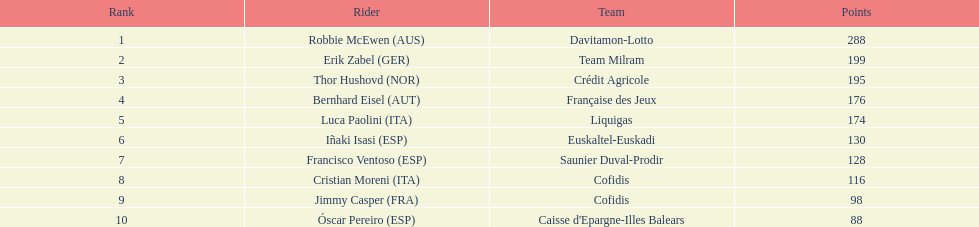What is the combined score of robbie mcewen and cristian moreni? 404. 